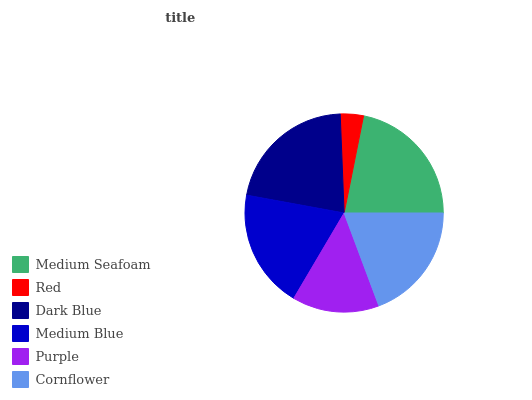Is Red the minimum?
Answer yes or no. Yes. Is Medium Seafoam the maximum?
Answer yes or no. Yes. Is Dark Blue the minimum?
Answer yes or no. No. Is Dark Blue the maximum?
Answer yes or no. No. Is Dark Blue greater than Red?
Answer yes or no. Yes. Is Red less than Dark Blue?
Answer yes or no. Yes. Is Red greater than Dark Blue?
Answer yes or no. No. Is Dark Blue less than Red?
Answer yes or no. No. Is Medium Blue the high median?
Answer yes or no. Yes. Is Cornflower the low median?
Answer yes or no. Yes. Is Cornflower the high median?
Answer yes or no. No. Is Dark Blue the low median?
Answer yes or no. No. 